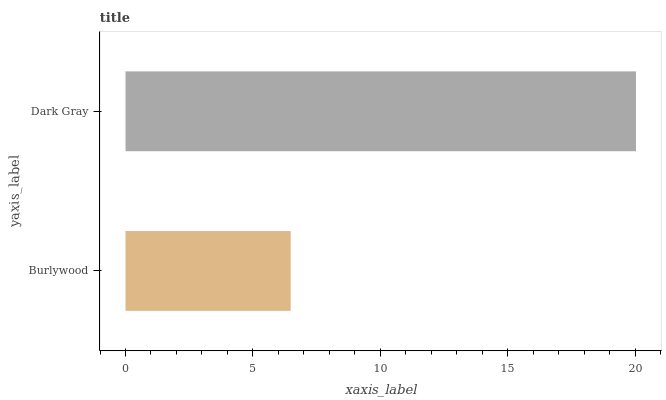Is Burlywood the minimum?
Answer yes or no. Yes. Is Dark Gray the maximum?
Answer yes or no. Yes. Is Dark Gray the minimum?
Answer yes or no. No. Is Dark Gray greater than Burlywood?
Answer yes or no. Yes. Is Burlywood less than Dark Gray?
Answer yes or no. Yes. Is Burlywood greater than Dark Gray?
Answer yes or no. No. Is Dark Gray less than Burlywood?
Answer yes or no. No. Is Dark Gray the high median?
Answer yes or no. Yes. Is Burlywood the low median?
Answer yes or no. Yes. Is Burlywood the high median?
Answer yes or no. No. Is Dark Gray the low median?
Answer yes or no. No. 